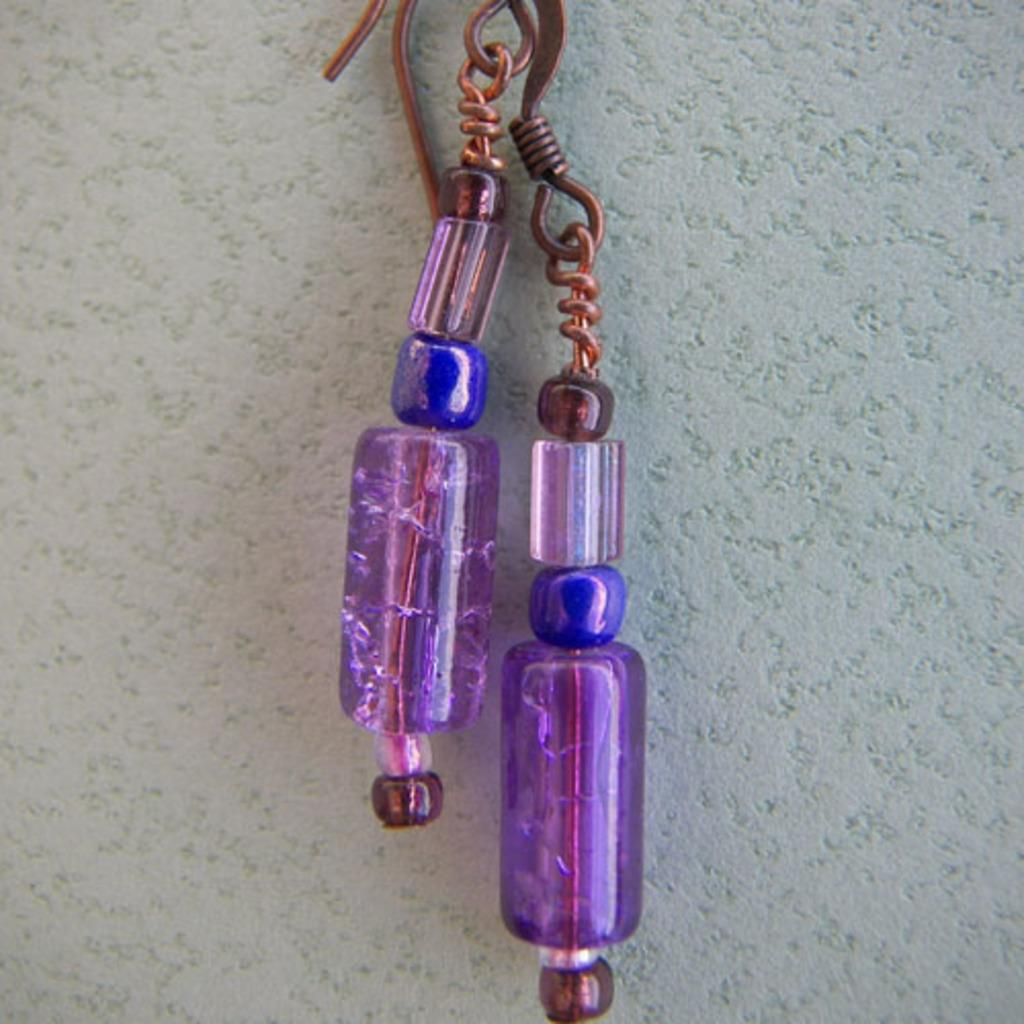What type of accessory is present in the picture? There are earrings in the picture. What can be seen in the background of the picture? There is a wall visible in the background of the picture. What type of unit is being played in the picture? There is no unit or musical instrument present in the picture; it only features earrings and a wall in the background. 